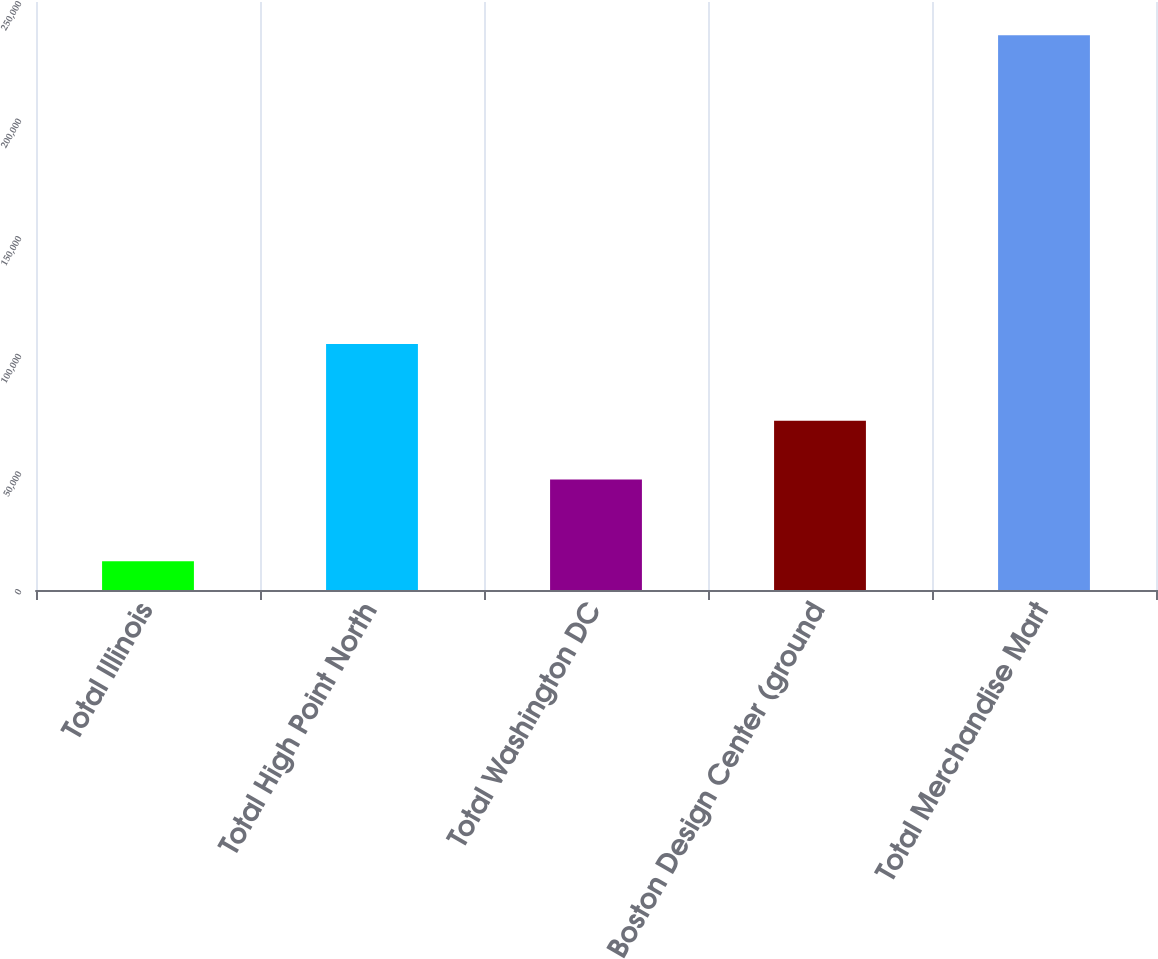<chart> <loc_0><loc_0><loc_500><loc_500><bar_chart><fcel>Total Illinois<fcel>Total High Point North<fcel>Total Washington DC<fcel>Boston Design Center (ground<fcel>Total Merchandise Mart<nl><fcel>12261<fcel>104639<fcel>46932<fcel>72000<fcel>235832<nl></chart> 